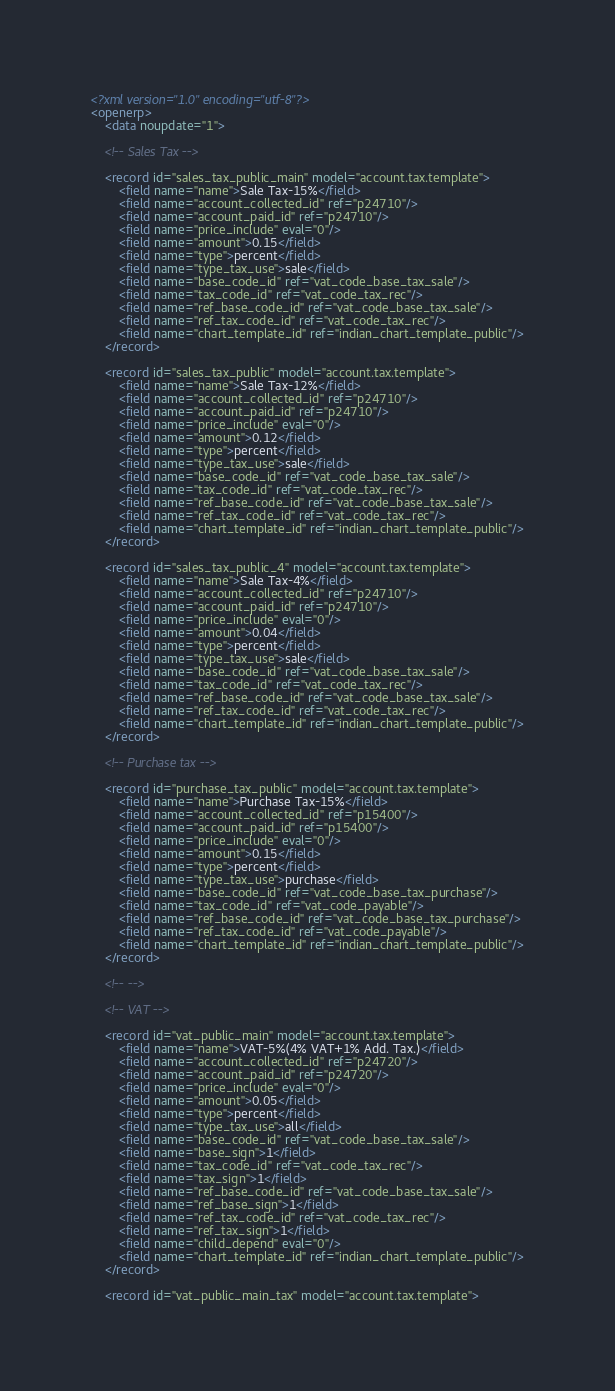<code> <loc_0><loc_0><loc_500><loc_500><_XML_><?xml version="1.0" encoding="utf-8"?>
<openerp>
    <data noupdate="1">
    
    <!-- Sales Tax -->
    
    <record id="sales_tax_public_main" model="account.tax.template">
        <field name="name">Sale Tax-15%</field>
        <field name="account_collected_id" ref="p24710"/>
        <field name="account_paid_id" ref="p24710"/> 
        <field name="price_include" eval="0"/>
        <field name="amount">0.15</field>
        <field name="type">percent</field>
        <field name="type_tax_use">sale</field>
        <field name="base_code_id" ref="vat_code_base_tax_sale"/>
        <field name="tax_code_id" ref="vat_code_tax_rec"/>
        <field name="ref_base_code_id" ref="vat_code_base_tax_sale"/>
        <field name="ref_tax_code_id" ref="vat_code_tax_rec"/>
        <field name="chart_template_id" ref="indian_chart_template_public"/>
    </record>
    
    <record id="sales_tax_public" model="account.tax.template">
        <field name="name">Sale Tax-12%</field>
        <field name="account_collected_id" ref="p24710"/>
        <field name="account_paid_id" ref="p24710"/> 
        <field name="price_include" eval="0"/>
        <field name="amount">0.12</field>
        <field name="type">percent</field>
        <field name="type_tax_use">sale</field>
        <field name="base_code_id" ref="vat_code_base_tax_sale"/>
        <field name="tax_code_id" ref="vat_code_tax_rec"/>
        <field name="ref_base_code_id" ref="vat_code_base_tax_sale"/>
        <field name="ref_tax_code_id" ref="vat_code_tax_rec"/>
        <field name="chart_template_id" ref="indian_chart_template_public"/>
    </record>
    
    <record id="sales_tax_public_4" model="account.tax.template">
        <field name="name">Sale Tax-4%</field>
        <field name="account_collected_id" ref="p24710"/>
        <field name="account_paid_id" ref="p24710"/> 
        <field name="price_include" eval="0"/>
        <field name="amount">0.04</field>
        <field name="type">percent</field>
        <field name="type_tax_use">sale</field>
        <field name="base_code_id" ref="vat_code_base_tax_sale"/>
        <field name="tax_code_id" ref="vat_code_tax_rec"/>
        <field name="ref_base_code_id" ref="vat_code_base_tax_sale"/>
        <field name="ref_tax_code_id" ref="vat_code_tax_rec"/>
        <field name="chart_template_id" ref="indian_chart_template_public"/>
    </record>
    
    <!-- Purchase tax -->
    
    <record id="purchase_tax_public" model="account.tax.template">
        <field name="name">Purchase Tax-15%</field>
        <field name="account_collected_id" ref="p15400"/>
        <field name="account_paid_id" ref="p15400"/> 
        <field name="price_include" eval="0"/>
        <field name="amount">0.15</field>
        <field name="type">percent</field>
        <field name="type_tax_use">purchase</field>
        <field name="base_code_id" ref="vat_code_base_tax_purchase"/>
        <field name="tax_code_id" ref="vat_code_payable"/>
        <field name="ref_base_code_id" ref="vat_code_base_tax_purchase"/>
        <field name="ref_tax_code_id" ref="vat_code_payable"/>
        <field name="chart_template_id" ref="indian_chart_template_public"/>
    </record>
    
    <!-- -->
    
    <!-- VAT -->
    
    <record id="vat_public_main" model="account.tax.template">
        <field name="name">VAT-5%(4% VAT+1% Add. Tax.)</field>
        <field name="account_collected_id" ref="p24720"/>
        <field name="account_paid_id" ref="p24720"/> 
        <field name="price_include" eval="0"/>
        <field name="amount">0.05</field>
        <field name="type">percent</field>
        <field name="type_tax_use">all</field>
        <field name="base_code_id" ref="vat_code_base_tax_sale"/>
        <field name="base_sign">1</field>
        <field name="tax_code_id" ref="vat_code_tax_rec"/>
        <field name="tax_sign">1</field>
        <field name="ref_base_code_id" ref="vat_code_base_tax_sale"/>
        <field name="ref_base_sign">1</field>
        <field name="ref_tax_code_id" ref="vat_code_tax_rec"/>
        <field name="ref_tax_sign">1</field>
        <field name="child_depend" eval="0"/>
        <field name="chart_template_id" ref="indian_chart_template_public"/>
    </record>

    <record id="vat_public_main_tax" model="account.tax.template"></code> 